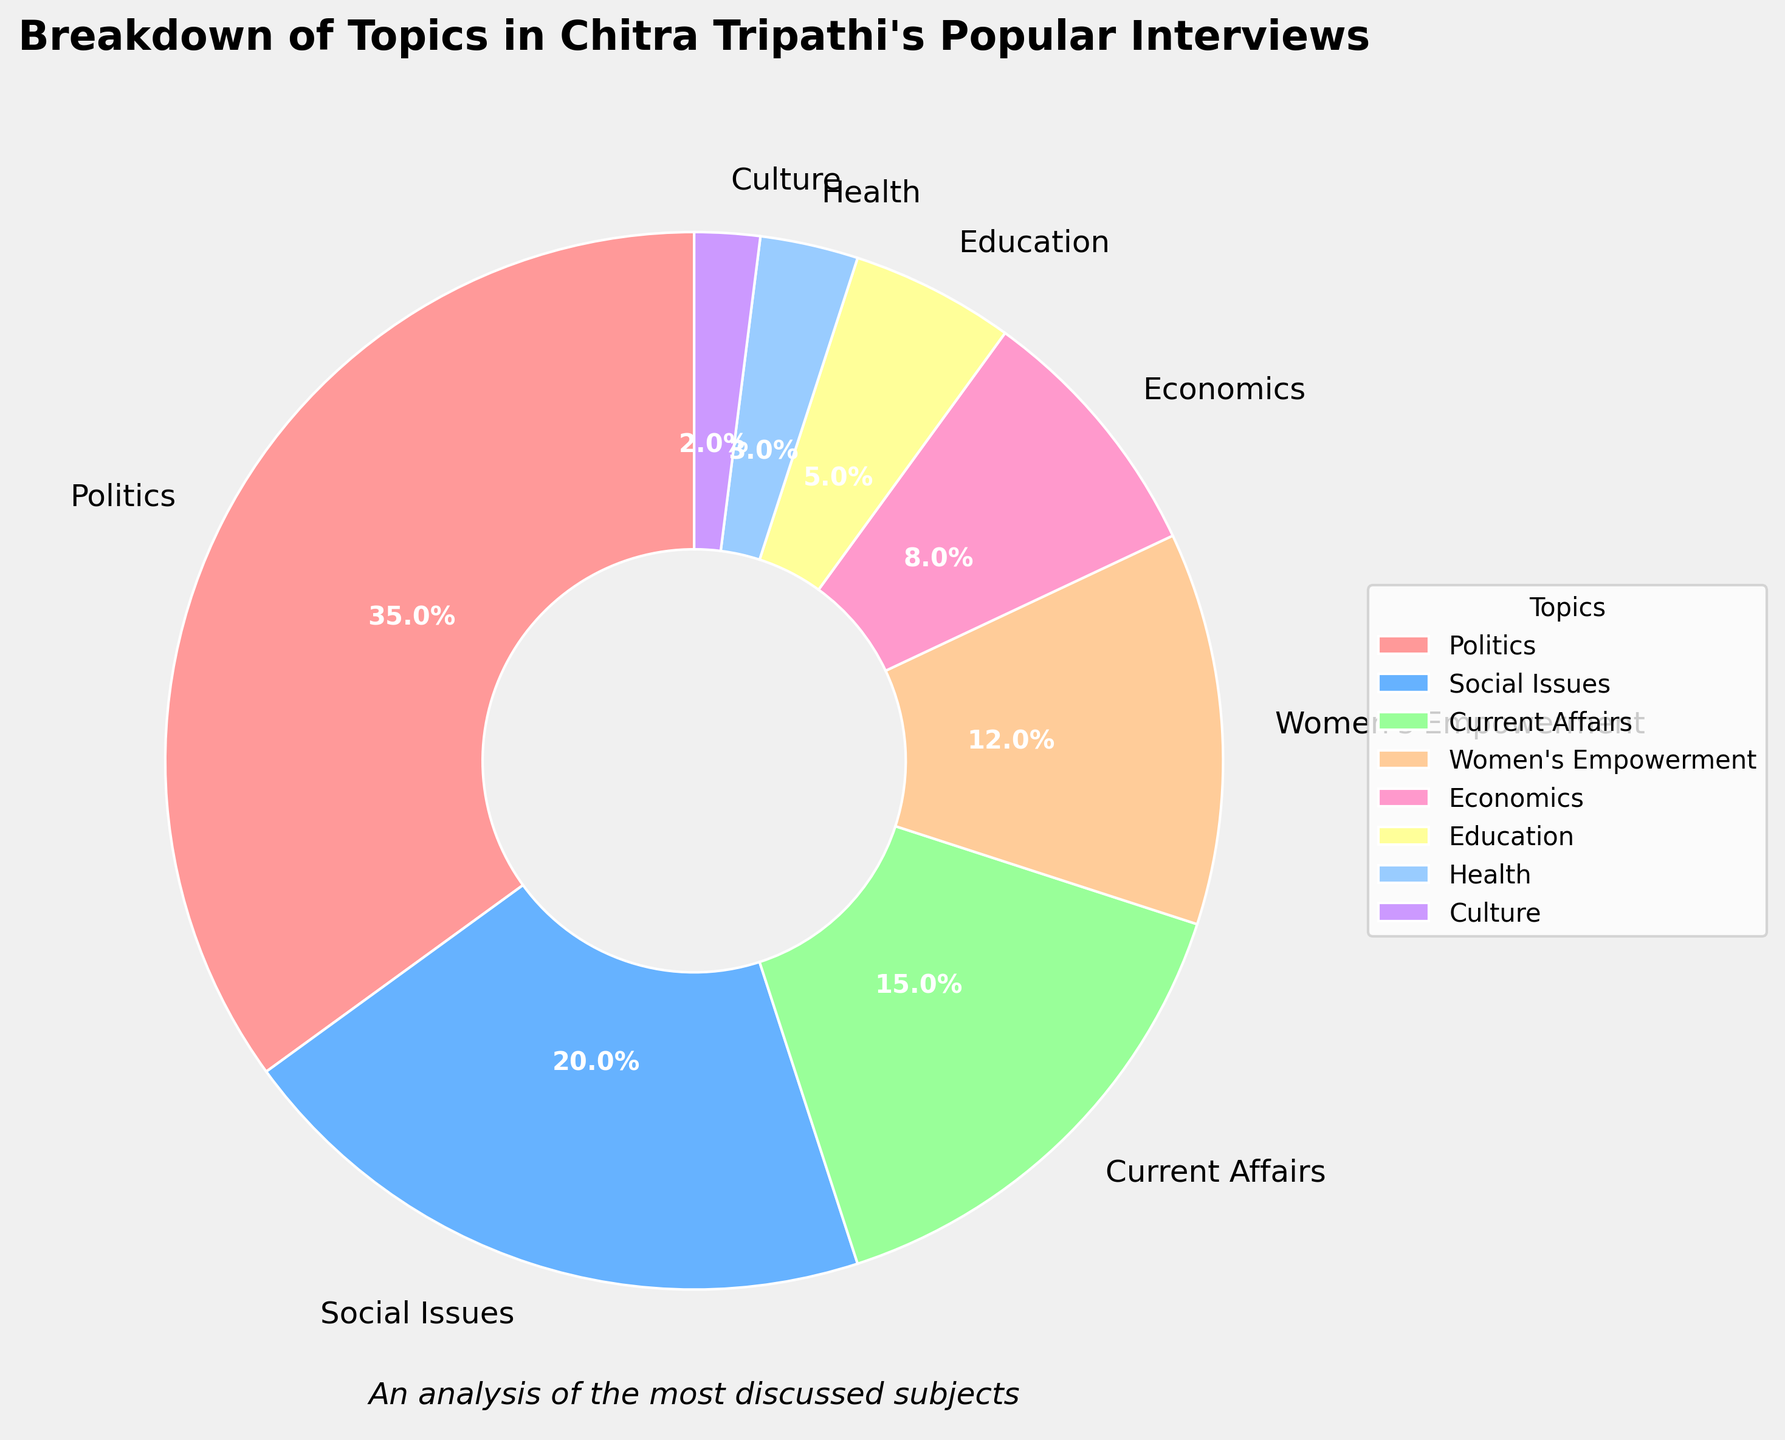What's the most covered topic in Chitra Tripathi's popular interviews? Based on the pie chart, the largest segment represents the most covered topic. The label associated with this segment is "Politics," which covers 35%.
Answer: Politics Which topic has the second highest coverage? The second largest segment in the pie chart corresponds to the topic "Social Issues," which makes up 20%.
Answer: Social Issues What is the combined percentage of interviews that covered Women's Empowerment and Education? Adding the percentages of Women's Empowerment (12%) and Education (5%): 12% + 5% = 17%.
Answer: 17% How much more coverage does Current Affairs have than Culture? Subtract the percentage of Culture from Current Affairs: 15% (Current Affairs) - 2% (Culture) = 13%.
Answer: 13% Which topic has the least coverage in Chitra Tripathi's popular interviews and what is its percentage? The smallest segment in the pie chart corresponds to "Culture," which covers 2%.
Answer: Culture, 2% What is the total percentage of topics other than Politics and Social Issues? First, sum the percentages of Politics and Social Issues: 35% + 20% = 55%. Then subtract this sum from 100%: 100% - 55% = 45%.
Answer: 45% If we combine the percentages for Health, Culture, and Education, what percentage do they account for? Adding the percentages of Health (3%), Culture (2%), and Education (5%): 3% + 2% + 5% = 10%.
Answer: 10% Which topic has a greater percentage: Economics or Women's Empowerment? By how much? Women's Empowerment covers 12%, while Economics covers 8%. Subtract Economics' percentage from Women's Empowerment's: 12% - 8% = 4%.
Answer: Women's Empowerment, 4% How does the coverage of Social Issues compare to the combined coverage of Health and Culture? Social Issues cover 20%. Combined coverage of Health (3%) and Culture (2%) is: 3% + 2% = 5%. Comparing these: 20% (Social Issues) is significantly more than 5% (Health + Culture).
Answer: 20% more 